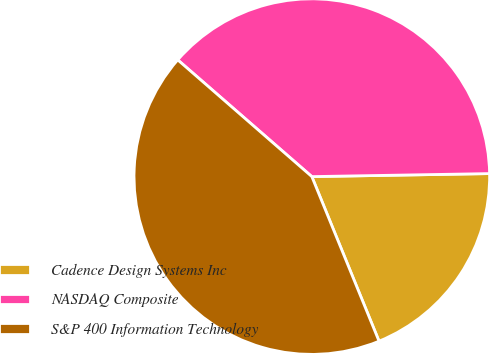<chart> <loc_0><loc_0><loc_500><loc_500><pie_chart><fcel>Cadence Design Systems Inc<fcel>NASDAQ Composite<fcel>S&P 400 Information Technology<nl><fcel>19.1%<fcel>38.33%<fcel>42.57%<nl></chart> 